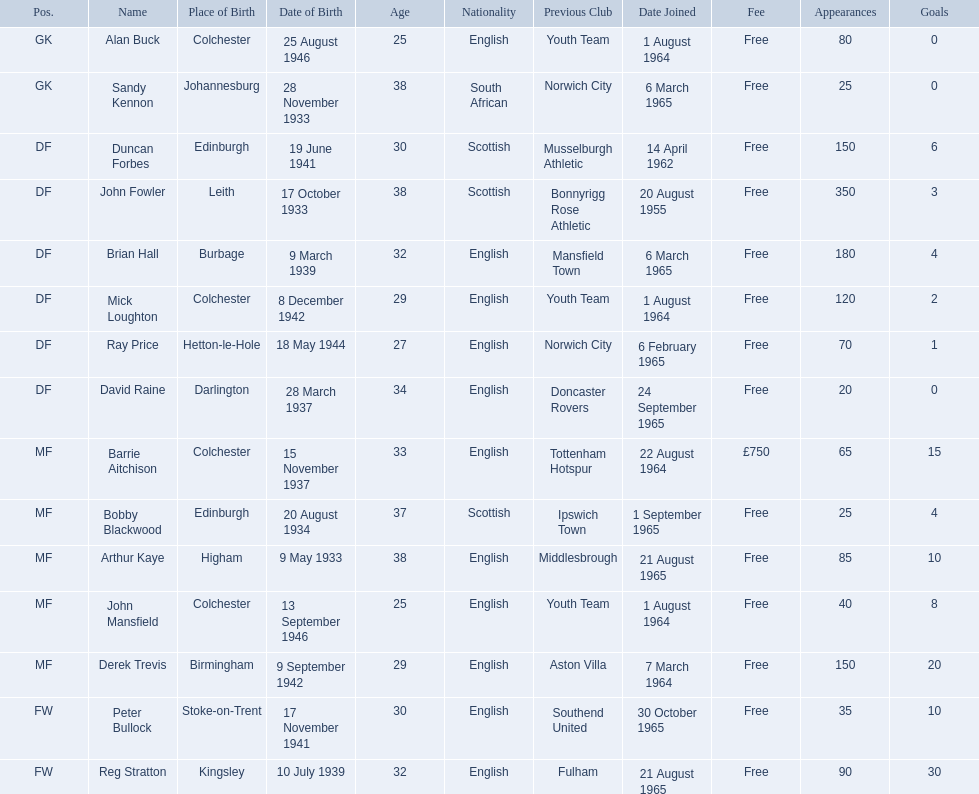Who are all the players? Alan Buck, Sandy Kennon, Duncan Forbes, John Fowler, Brian Hall, Mick Loughton, Ray Price, David Raine, Barrie Aitchison, Bobby Blackwood, Arthur Kaye, John Mansfield, Derek Trevis, Peter Bullock, Reg Stratton. What dates did the players join on? 1 August 1964, 6 March 1965, 14 April 1962, 20 August 1955, 6 March 1965, 1 August 1964, 6 February 1965, 24 September 1965, 22 August 1964, 1 September 1965, 21 August 1965, 1 August 1964, 7 March 1964, 30 October 1965, 21 August 1965. Who is the first player who joined? John Fowler. What is the date of the first person who joined? 20 August 1955. 